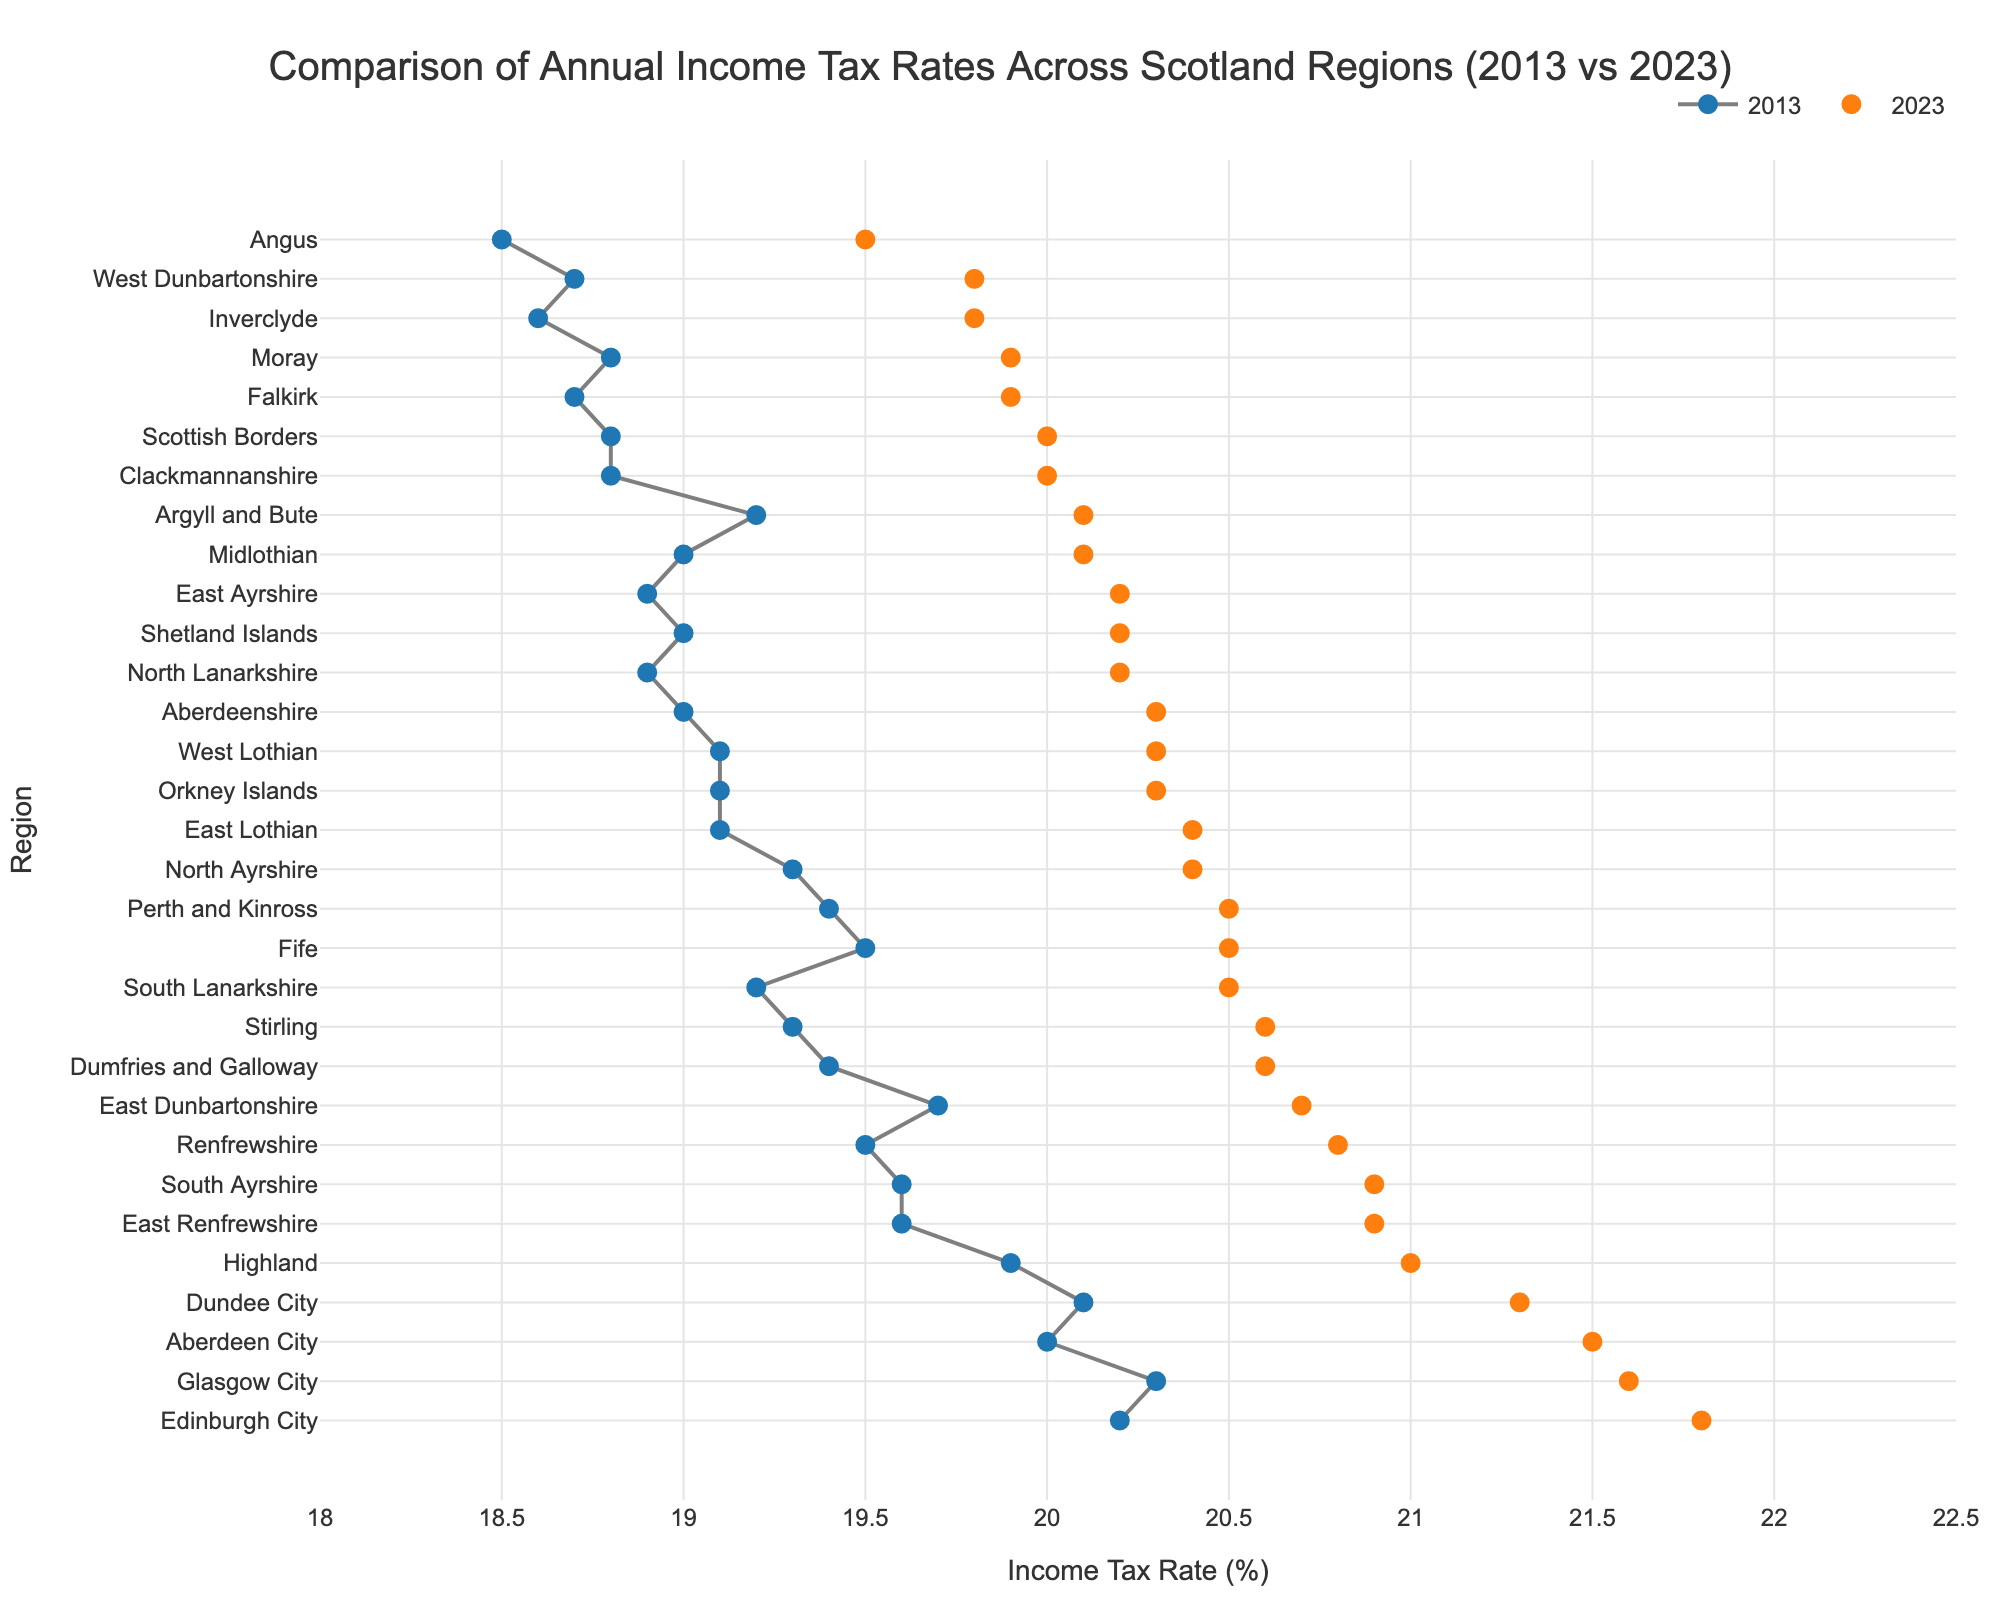What is the overall trend in income tax rates from 2013 to 2023 across the regions? By analyzing the lines between 2013 and 2023 markers, it is evident that all regions show an increase in income tax rates from 2013 to 2023. This overall upward trend indicates that income tax rates have generally risen over the decade.
Answer: Increase How many regions have income tax rates higher than 20.5% in 2023? We can count the number of 2023 markers that are positioned at or above the 20.5% tax rate on the x-axis. The regions that have rates higher than 20.5% in 2023 are: Aberdeen City, Dundee City, East Renfrewshire, Edinburgh City, Glasgow City, Highland, Renfrewshire, and South Ayrshire.
Answer: 8 Which region had the highest income tax rate in 2023? By checking the 2023 markers, the region with the highest income tax rate is Edinburgh City, as it has the marker furthest along the x-axis at 21.8%.
Answer: Edinburgh City Which region had the lowest income tax rate in 2013? By examining the 2013 markers, the region with the lowest income tax rate is Angus, at 18.5%, as it is the marker furthest left on the x-axis.
Answer: Angus What was the increase in income tax rate for Aberdeen City from 2013 to 2023? Subtracting the 2013 income tax rate for Aberdeen City (20.0%) from the 2023 rate (21.5%) gives the increase.
Answer: 1.5% Which regions have a higher income tax rate in 2023 compared to Inverclyde? Inverclyde has a 2023 income tax rate of 19.8%. A comparison with the other regions based on their 2023 markers shows that Aberdeen City, Aberdeenshire, Argyll and Bute, Clackmannanshire, Dumfries and Galloway, Dundee City, East Ayrshire, East Dunbartonshire, East Lothian, East Renfrewshire, Edinburgh City, Fife, Glasgow City, Highland, Midlothian, Moray, North Ayrshire, North Lanarkshire, Orkney Islands, Perth and Kinross, Renfrewshire, Scottish Borders, Shetland Islands, South Ayrshire, South Lanarkshire, Stirling, and West Lothian have higher rates than Inverclyde.
Answer: 27 regions What's the average increase in income tax rate across all regions from 2013 to 2023? To find this, calculate the difference for each region, sum these differences, and divide by the number of regions. The differences and their sum would be (21.5 - 20.0) + (20.3 - 19.0) + (19.5 - 18.5) + (20.1 - 19.2) + (20.0 - 18.8) + (20.6 - 19.4) + (21.3 - 20.1) + (20.2 - 18.9) + (20.7 - 19.7) + (20.4 - 19.1) + (20.9 - 19.6) + (21.8 - 20.2) + (19.9 - 18.7) + (20.5 - 19.5) + (21.6 - 20.3) + (21.0 - 19.9) + (19.8 - 18.6) + (20.1 - 19.0) + (19.9 - 18.8) + (20.4 - 19.3) + (20.2 - 18.9) + (20.3 - 19.1) + (20.5 - 19.4) + (20.8 - 19.5) + (20.0 - 18.8) + (20.2 - 19.0) + (20.9 - 19.6) + (20.5 - 19.2) + (20.6 - 19.3) + (19.8 - 18.7) + (20.3 - 19.1) = 30.1. Dividing this sum by 31 regions, the average increase is 0.97+.
Answer: 0.97 